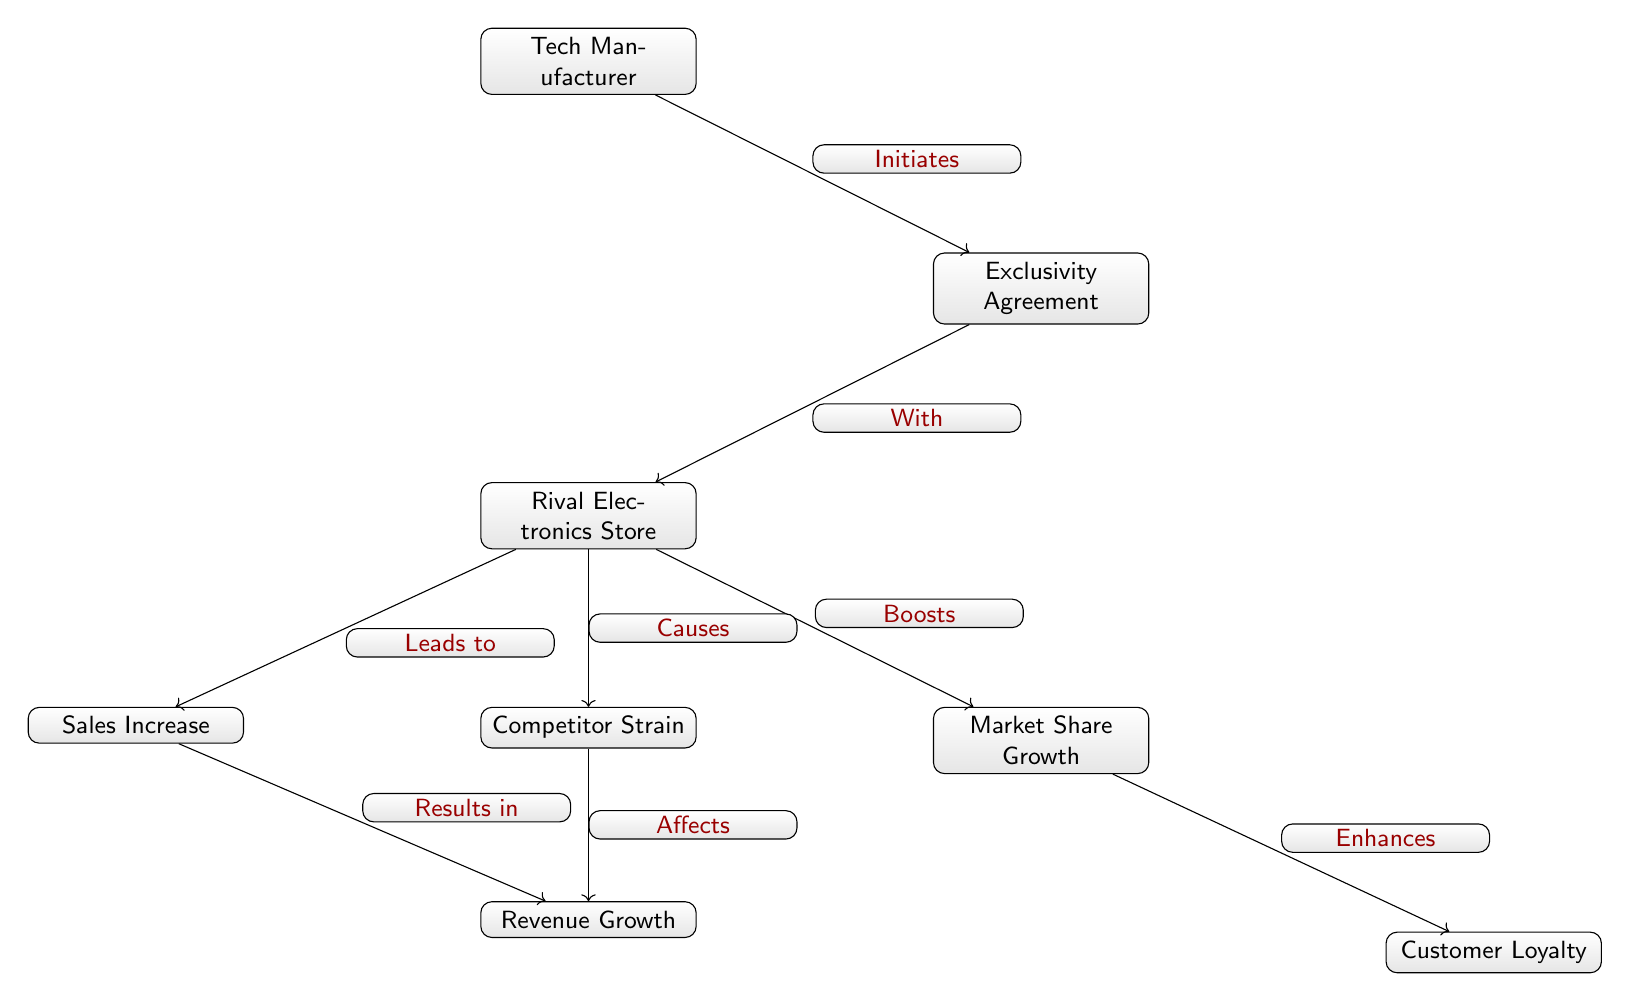What entity initiates the exclusivity agreement? The diagram shows that the Tech Manufacturer is the entity that initiates the exclusivity agreement, as indicated by the arrow pointing from "Tech Manufacturer" to "Exclusivity Agreement" labeled "Initiates."
Answer: Tech Manufacturer What does the exclusivity agreement lead to? According to the diagram, the exclusivity agreement leads to impacts on the Rival Electronics Store, as represented by the arrow pointing from "Exclusivity Agreement" to "Rival Electronics Store."
Answer: Rival Electronics Store How many nodes are in the diagram? By counting the distinct labeled shapes in the diagram, there are a total of seven nodes: Tech Manufacturer, Exclusivity Agreement, Rival Electronics Store, Sales Increase, Market Share Growth, Customer Loyalty, and Competitor Strain.
Answer: Seven What effect does the rival electronics store's sales increase have? The sales increase results in revenue growth, as shown by the flow of the diagram from "Sales Increase" to "Revenue Growth," which is labeled "Results in."
Answer: Revenue Growth What is enhanced by market share growth? The diagram indicates that customer loyalty is enhanced as a result of market share growth, with the arrow pointing from "Market Share Growth" to "Customer Loyalty" marked "Enhances."
Answer: Customer Loyalty What does the rival electronics store cause in terms of competition? The diagram illustrates that the rival electronics store causes competitor strain, as shown by the arrow from "Rival Electronics Store" to "Competitor Strain" with the label "Causes."
Answer: Competitor Strain How does competitor strain affect revenue growth? The diagram connects competitor strain to revenue growth with an arrow labeled "Affects." This indicates that competitor strain has a direct impact on the revenue growth of the rival electronics store.
Answer: Affects What leads to a boost in market share? The relationship shown in the diagram indicates that the rival electronics store leads to a boost in market share, as represented by the arrow pointing from "Rival Electronics Store" to "Market Share Growth" labeled "Boosts."
Answer: Boosts What initiates the sequence in the diagram? The sequence is initiated by the Tech Manufacturer, which starts the flow of relationships leading to various outcomes affecting the rival electronics store and its parameters.
Answer: Tech Manufacturer 